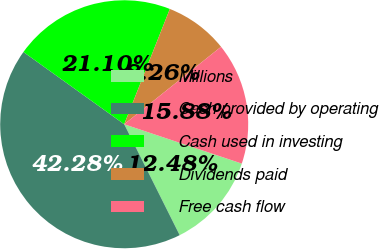Convert chart to OTSL. <chart><loc_0><loc_0><loc_500><loc_500><pie_chart><fcel>Millions<fcel>Cash provided by operating<fcel>Cash used in investing<fcel>Dividends paid<fcel>Free cash flow<nl><fcel>12.48%<fcel>42.28%<fcel>21.1%<fcel>8.26%<fcel>15.88%<nl></chart> 